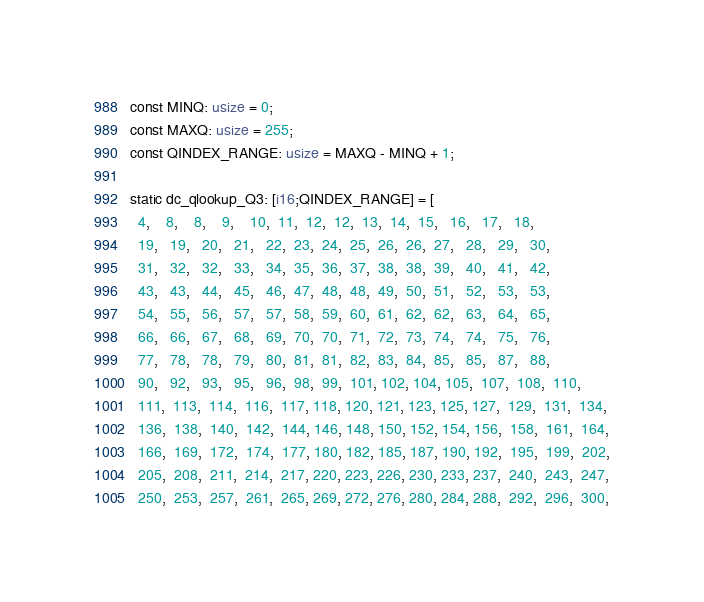Convert code to text. <code><loc_0><loc_0><loc_500><loc_500><_Rust_>const MINQ: usize = 0;
const MAXQ: usize = 255;
const QINDEX_RANGE: usize = MAXQ - MINQ + 1;

static dc_qlookup_Q3: [i16;QINDEX_RANGE] = [
  4,    8,    8,    9,    10,  11,  12,  12,  13,  14,  15,   16,   17,   18,
  19,   19,   20,   21,   22,  23,  24,  25,  26,  26,  27,   28,   29,   30,
  31,   32,   32,   33,   34,  35,  36,  37,  38,  38,  39,   40,   41,   42,
  43,   43,   44,   45,   46,  47,  48,  48,  49,  50,  51,   52,   53,   53,
  54,   55,   56,   57,   57,  58,  59,  60,  61,  62,  62,   63,   64,   65,
  66,   66,   67,   68,   69,  70,  70,  71,  72,  73,  74,   74,   75,   76,
  77,   78,   78,   79,   80,  81,  81,  82,  83,  84,  85,   85,   87,   88,
  90,   92,   93,   95,   96,  98,  99,  101, 102, 104, 105,  107,  108,  110,
  111,  113,  114,  116,  117, 118, 120, 121, 123, 125, 127,  129,  131,  134,
  136,  138,  140,  142,  144, 146, 148, 150, 152, 154, 156,  158,  161,  164,
  166,  169,  172,  174,  177, 180, 182, 185, 187, 190, 192,  195,  199,  202,
  205,  208,  211,  214,  217, 220, 223, 226, 230, 233, 237,  240,  243,  247,
  250,  253,  257,  261,  265, 269, 272, 276, 280, 284, 288,  292,  296,  300,</code> 